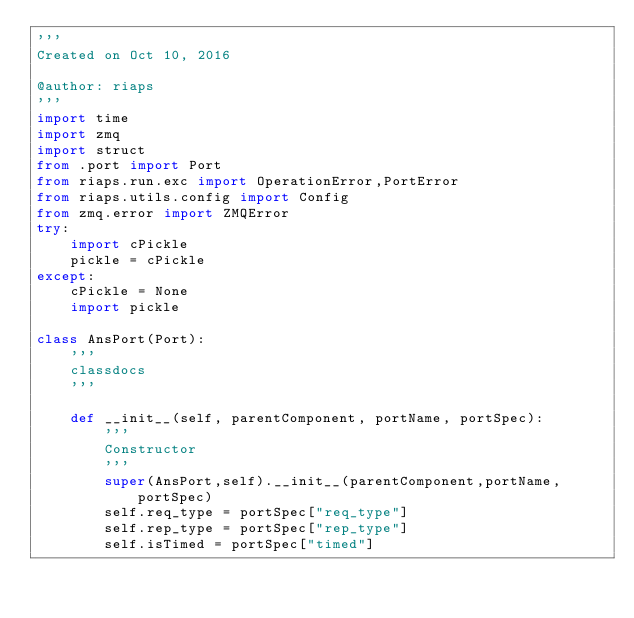<code> <loc_0><loc_0><loc_500><loc_500><_Python_>'''
Created on Oct 10, 2016

@author: riaps
'''
import time
import zmq
import struct
from .port import Port
from riaps.run.exc import OperationError,PortError
from riaps.utils.config import Config
from zmq.error import ZMQError
try:
    import cPickle
    pickle = cPickle
except:
    cPickle = None
    import pickle
    
class AnsPort(Port):
    '''
    classdocs
    '''

    def __init__(self, parentComponent, portName, portSpec):
        '''
        Constructor
        '''
        super(AnsPort,self).__init__(parentComponent,portName,portSpec)
        self.req_type = portSpec["req_type"]
        self.rep_type = portSpec["rep_type"]
        self.isTimed = portSpec["timed"]</code> 